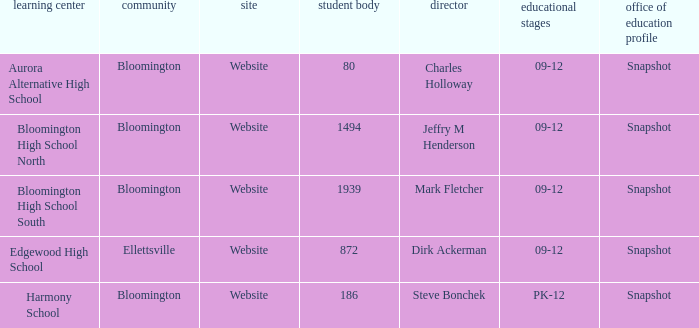How many websites are there for the school with 1939 students? 1.0. 